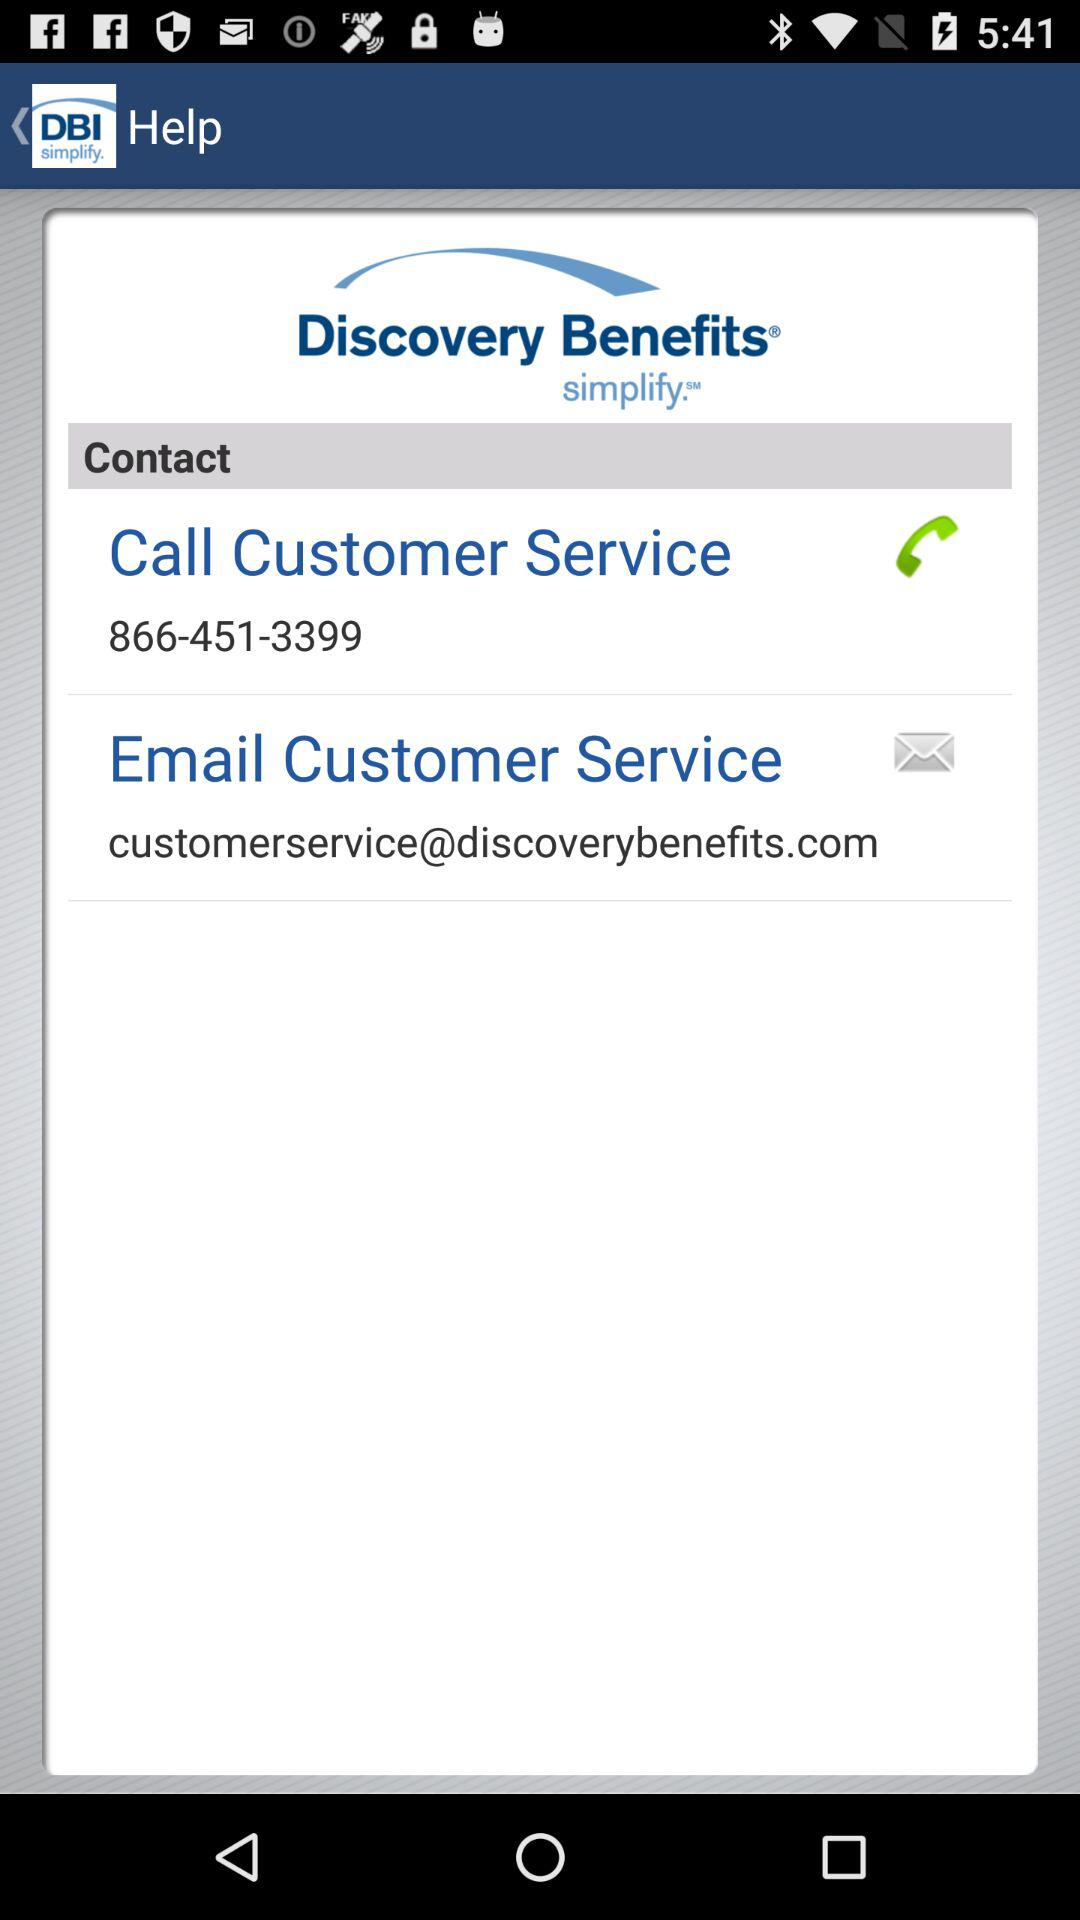What is "Email Customer Service"? The "Email Customer Service" is customerservice@discoverybenefits.com. 